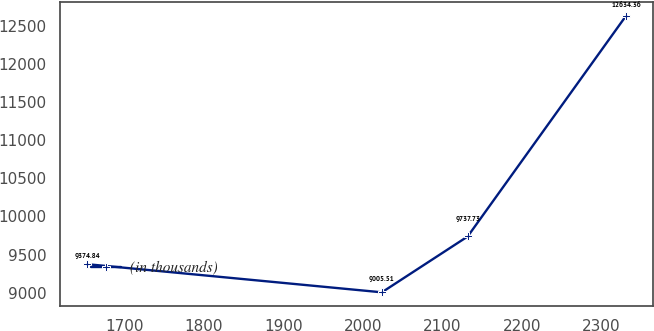Convert chart to OTSL. <chart><loc_0><loc_0><loc_500><loc_500><line_chart><ecel><fcel>(in thousands)<nl><fcel>1653.18<fcel>9374.84<nl><fcel>2023.86<fcel>9005.51<nl><fcel>2131.66<fcel>9737.73<nl><fcel>2330.89<fcel>12634.4<nl></chart> 